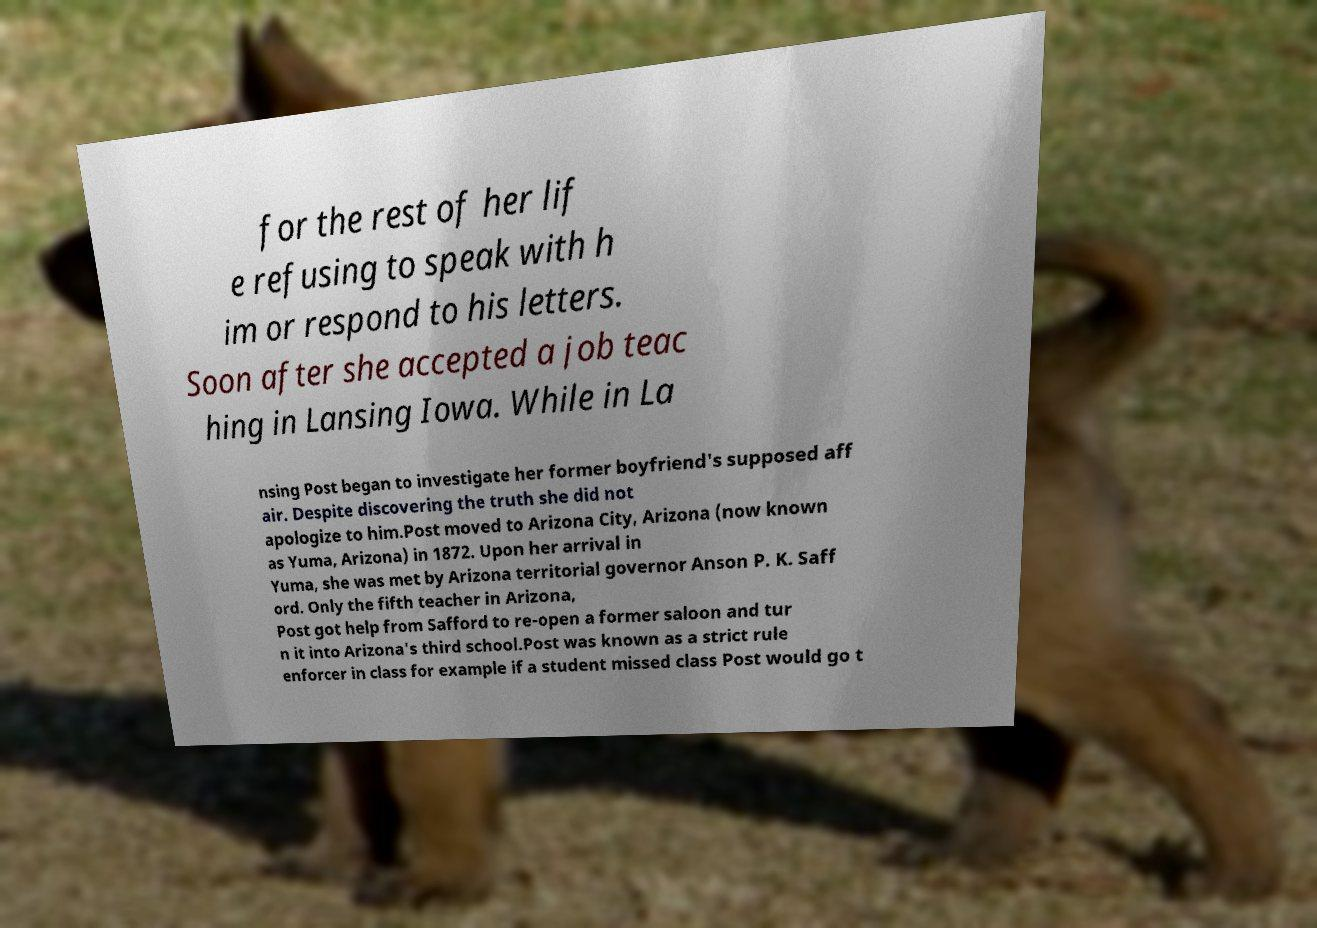For documentation purposes, I need the text within this image transcribed. Could you provide that? for the rest of her lif e refusing to speak with h im or respond to his letters. Soon after she accepted a job teac hing in Lansing Iowa. While in La nsing Post began to investigate her former boyfriend's supposed aff air. Despite discovering the truth she did not apologize to him.Post moved to Arizona City, Arizona (now known as Yuma, Arizona) in 1872. Upon her arrival in Yuma, she was met by Arizona territorial governor Anson P. K. Saff ord. Only the fifth teacher in Arizona, Post got help from Safford to re-open a former saloon and tur n it into Arizona's third school.Post was known as a strict rule enforcer in class for example if a student missed class Post would go t 